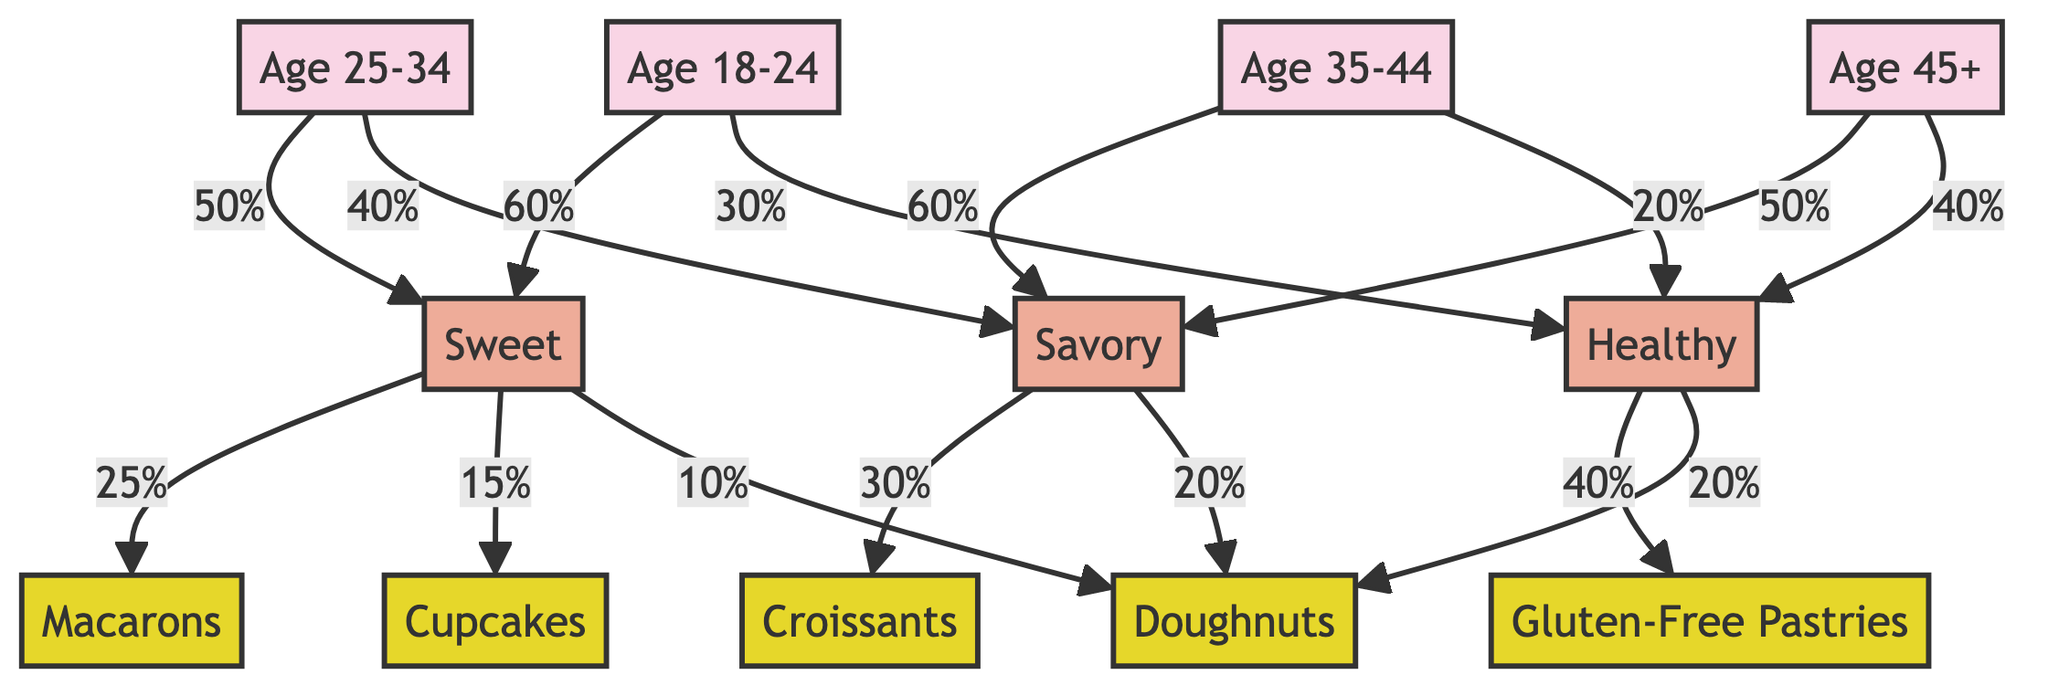What percentage of the 18-24 age group prefers sweet pastries? The diagram shows that the 18-24 age group (AG1) has a 60% preference for sweet pastries (TP1).
Answer: 60% Which age group has the highest preference for savory pastries? In the diagram, the 35-44 age group (AG3) and the 25-34 age group (AG2) both show preferences for savory pastries (TP2) at 60% and 40% respectively. Therefore, the highest preference is 60% from AG3.
Answer: Age 35-44 What type of pastry is favored the most by those who prefer healthy options? Looking at the diagram, the healthy preference (TP3) leads to Gluten-Free Pastries (PT5) being the favored type at 40%.
Answer: Gluten-Free Pastries How many total pastry types are represented in the diagram? The diagram outlines five pastry types: Macarons, Croissants, Cupcakes, Doughnuts, and Gluten-Free Pastries. Thus, totaling five pastry types.
Answer: 5 What is the percentage of 25-34 year-olds that prefer savory pastries? From the diagram, the age group 25-34 (AG2) has a preference of 40% for savory pastries (TP2).
Answer: 40% Which age group has the highest percentage preference for cupcakes? The diagram indicates that 15% of the sweet preference (TP1) comes from age 18-24 (AG1) for cupcakes (PT3), no other age group has a higher percentage shown for cupcakes.
Answer: Age 18-24 What age group shows an equal preference for sweet and healthy pastries? Analyzing the diagram, the 18-24 age group (AG1) has a 60% preference for sweet (TP1) and a 30% for healthy (TP3), but no age group shows equal percentages between sweet and healthy.
Answer: None In which age group do doughnuts rank as the most preferred pastry type? From the diagram, doughnuts (PT4) are preferred by the 25-34 age group at 10%, thus this group shows doughnuts as their top choice among the percentage calculations provided.
Answer: Age 25-34 How does the preference for savory pastries change among age groups? The diagram shows that the preference for savory pastries (TP2) is highest among the 35-44 age group at 60%, followed by 40% in the 25-34 age group, thus indicating a decrease as you move to younger groups.
Answer: Decreases with age groups 